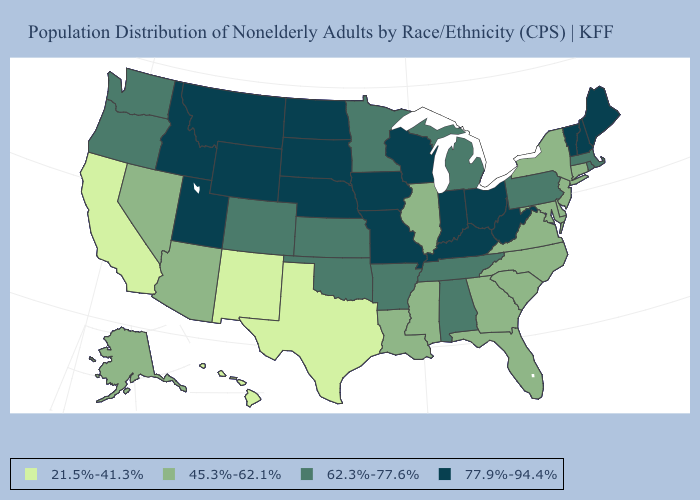Does Montana have the lowest value in the West?
Quick response, please. No. What is the value of Hawaii?
Write a very short answer. 21.5%-41.3%. Does the first symbol in the legend represent the smallest category?
Keep it brief. Yes. What is the value of Missouri?
Keep it brief. 77.9%-94.4%. What is the highest value in states that border Kentucky?
Short answer required. 77.9%-94.4%. What is the value of Tennessee?
Answer briefly. 62.3%-77.6%. Name the states that have a value in the range 21.5%-41.3%?
Write a very short answer. California, Hawaii, New Mexico, Texas. What is the value of Iowa?
Write a very short answer. 77.9%-94.4%. Does Vermont have a lower value than Maryland?
Concise answer only. No. What is the lowest value in the USA?
Keep it brief. 21.5%-41.3%. Among the states that border Vermont , which have the highest value?
Short answer required. New Hampshire. What is the value of Delaware?
Give a very brief answer. 45.3%-62.1%. What is the lowest value in the USA?
Give a very brief answer. 21.5%-41.3%. Among the states that border Utah , does New Mexico have the highest value?
Write a very short answer. No. 